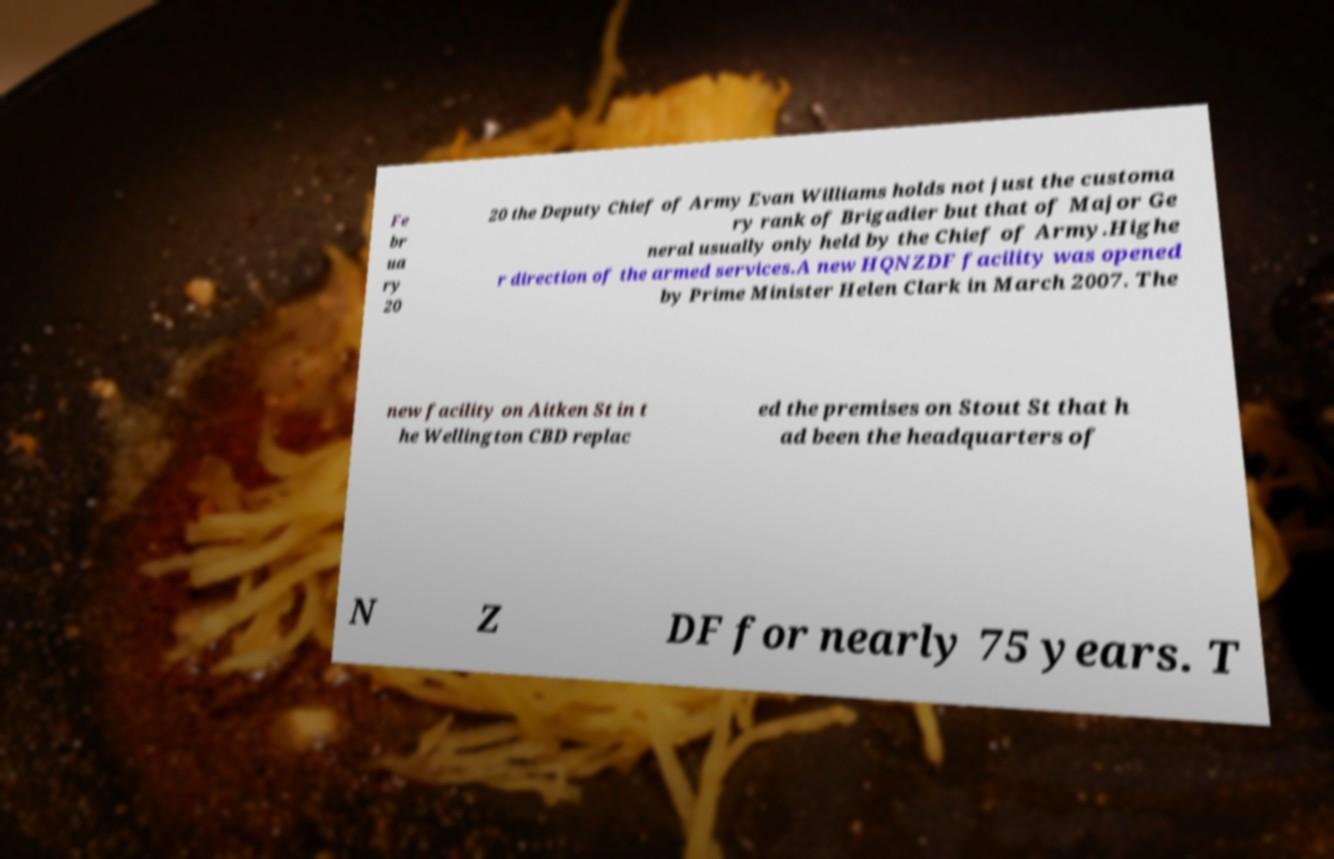There's text embedded in this image that I need extracted. Can you transcribe it verbatim? Fe br ua ry 20 20 the Deputy Chief of Army Evan Williams holds not just the customa ry rank of Brigadier but that of Major Ge neral usually only held by the Chief of Army.Highe r direction of the armed services.A new HQNZDF facility was opened by Prime Minister Helen Clark in March 2007. The new facility on Aitken St in t he Wellington CBD replac ed the premises on Stout St that h ad been the headquarters of N Z DF for nearly 75 years. T 